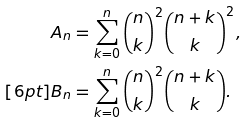<formula> <loc_0><loc_0><loc_500><loc_500>A _ { n } & = \sum _ { k = 0 } ^ { n } { n \choose k } ^ { 2 } { n + k \choose k } ^ { 2 } , \\ [ 6 p t ] B _ { n } & = \sum _ { k = 0 } ^ { n } { n \choose k } ^ { 2 } { n + k \choose k } .</formula> 